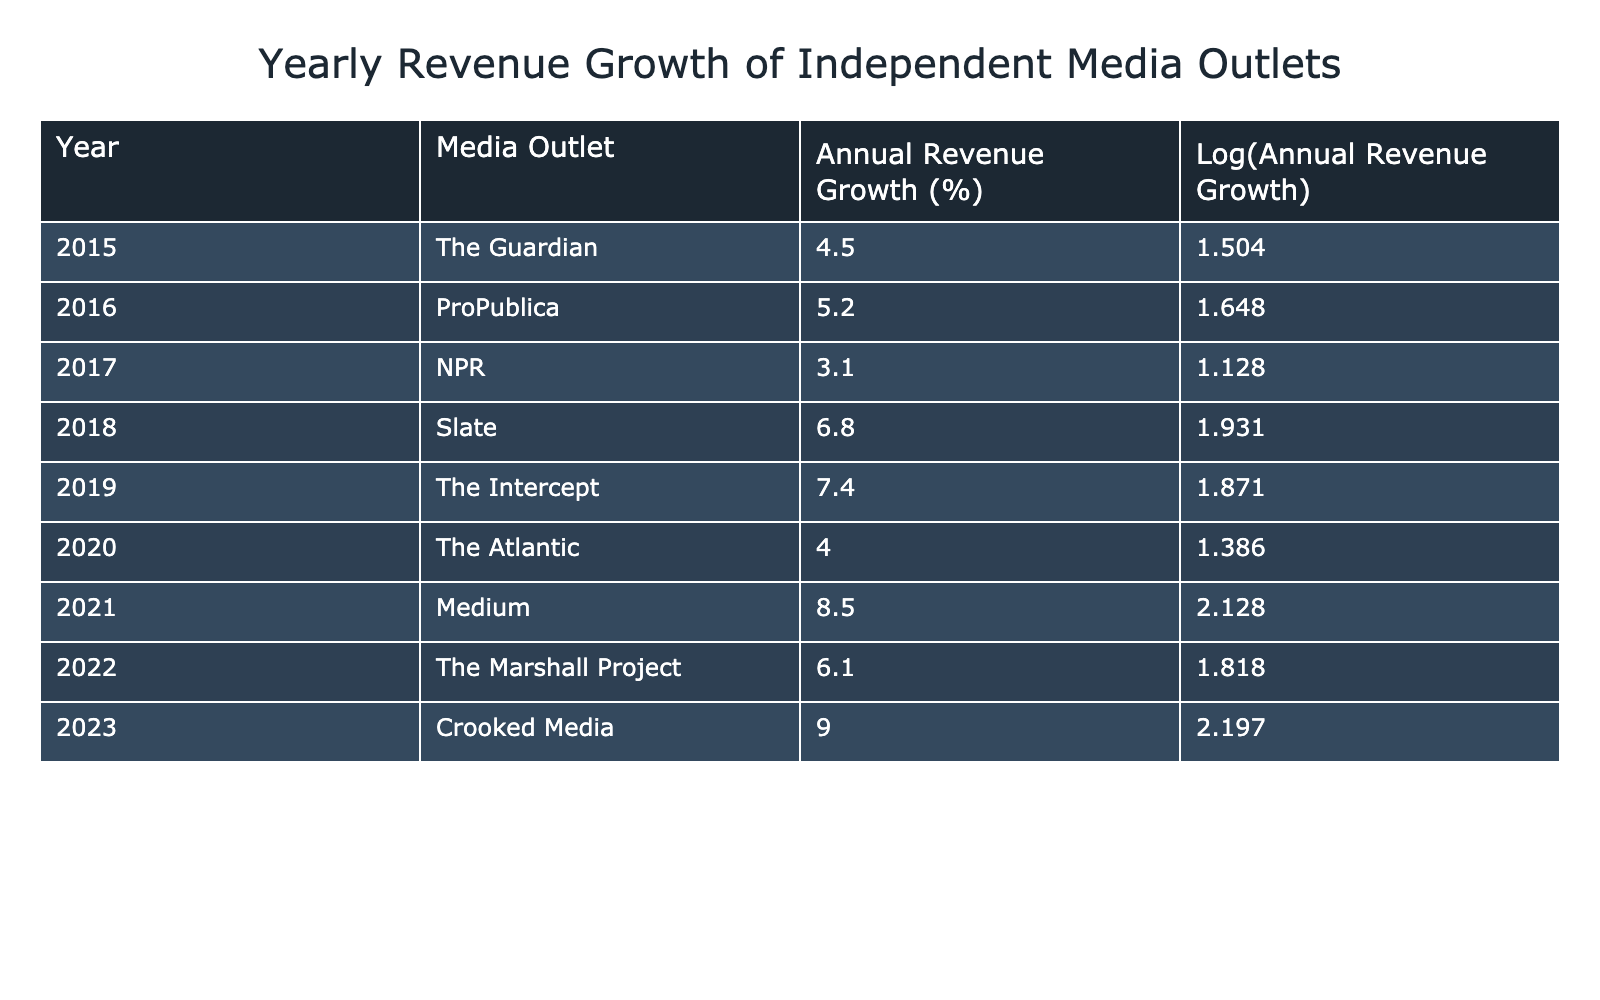What was the highest annual revenue growth percentage recorded in the table? The table shows annual revenue growth percentages for each media outlet per year. The maximum value can be found by comparing all the percentages listed. The maximum percentage is 9.0, corresponding to Crooked Media in 2023.
Answer: 9.0 Which media outlet showed a decrease in revenue growth from the previous year? By examining the annual revenue growth percentages year by year, we can see if any outlet has a lower percentage than in the previous year. NPR had a lower growth (3.1) in 2017 compared to ProPublica in 2016 (5.2), indicating a decrease in growth rate.
Answer: Yes, NPR showed a decrease What is the average annual revenue growth over the years presented in the table? To find the average, first, we sum all the annual revenue growth percentages: 4.5 + 5.2 + 3.1 + 6.8 + 7.4 + 4.0 + 8.5 + 6.1 + 9.0 = 54.6. Since there are 9 data points, the average is 54.6 / 9 = 6.067.
Answer: 6.067 Did The Guardian experience higher growth than The Atlantic in any year? Checking the percentages for The Guardian (4.5 in 2015 and 1.504 in log values) and The Atlantic (4.0 in 2020 and 1.386 in log values), we find that The Guardian had higher growth in 2015 compared to The Atlantic's 4.0 in 2020.
Answer: Yes, in 2015 What was the sum of annual revenue growth percentages for the years 2018 to 2020? We need to add the values for 2018 (Slate - 6.8), 2019 (The Intercept - 7.4), and 2020 (The Atlantic - 4.0). Thus, the sum is 6.8 + 7.4 + 4.0 = 18.2.
Answer: 18.2 Which outlet had the most significant increase in growth from 2019 to 2020? We find the growth percentages for both years: The Intercept in 2019 had growth of 7.4, and The Atlantic in 2020 had growth of 4.0. To assess the increase, we see there is actually a decrease from 7.4 to 4.0. Therefore, no outlet significantly increased growth in that time frame.
Answer: None What were the log values corresponding to the highest and lowest annual revenue growth percentages? The highest growth was 9.0 (Crooked Media) with a log value of 2.197, and the lowest was 3.1 (NPR) with a log value of 1.128. The log values can be directly referenced from the table alongside their respective growth percentages.
Answer: Highest: 2.197, Lowest: 1.128 In which year did Medium record the highest growth compared to its previous years? Analyzing Medium's growth (8.5 in 2021) indicates it was higher than its previous years’ growth values (none available since it was not present prior). Therefore, 8.5 in 2021 is indeed its highest recorded growth value since the outlet was new in the dataset.
Answer: 2021 